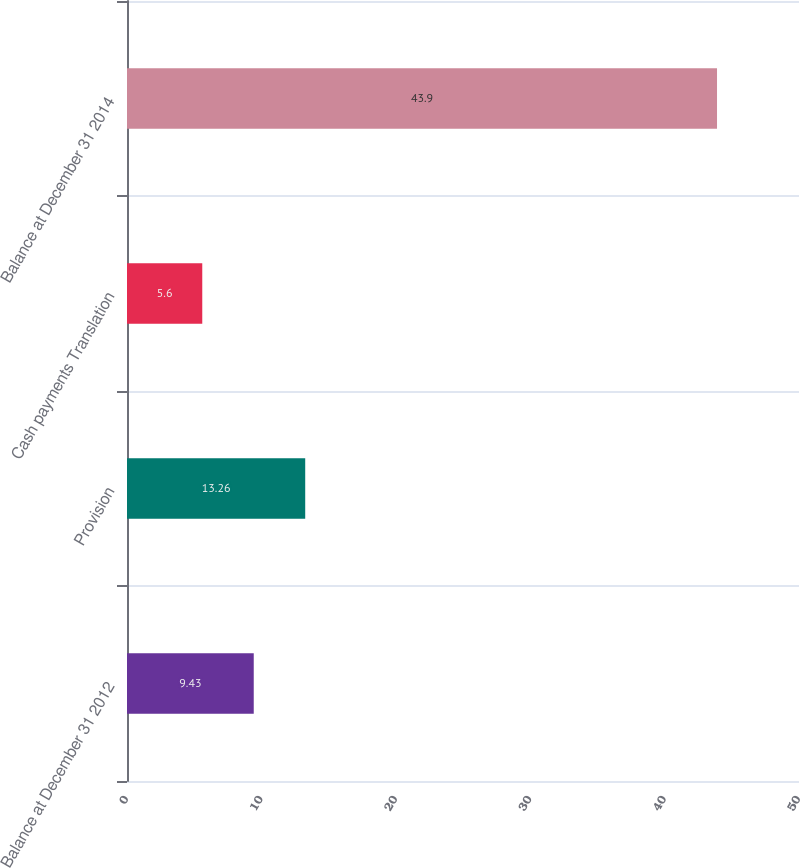<chart> <loc_0><loc_0><loc_500><loc_500><bar_chart><fcel>Balance at December 31 2012<fcel>Provision<fcel>Cash payments Translation<fcel>Balance at December 31 2014<nl><fcel>9.43<fcel>13.26<fcel>5.6<fcel>43.9<nl></chart> 